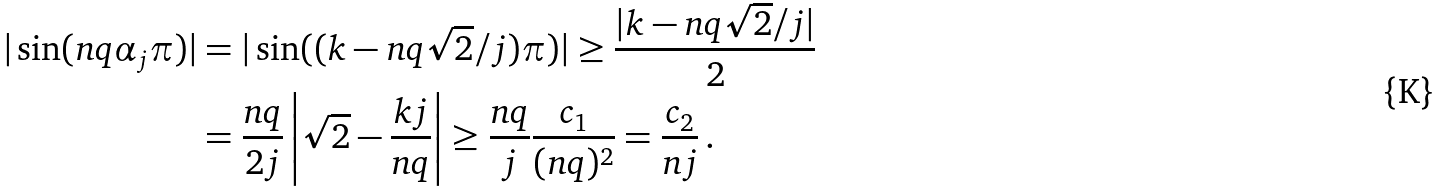Convert formula to latex. <formula><loc_0><loc_0><loc_500><loc_500>| \sin ( n q \alpha _ { j } \pi ) | & = | \sin ( ( k - n q \sqrt { 2 } / j ) \pi ) | \geq \frac { | k - n q \sqrt { 2 } / j | } { 2 } \\ & = \frac { n q } { 2 j } \left | \sqrt { 2 } - \frac { k j } { n q } \right | \geq \frac { n q } { j } \frac { c _ { 1 } } { ( n q ) ^ { 2 } } = \frac { c _ { 2 } } { n j } \, .</formula> 